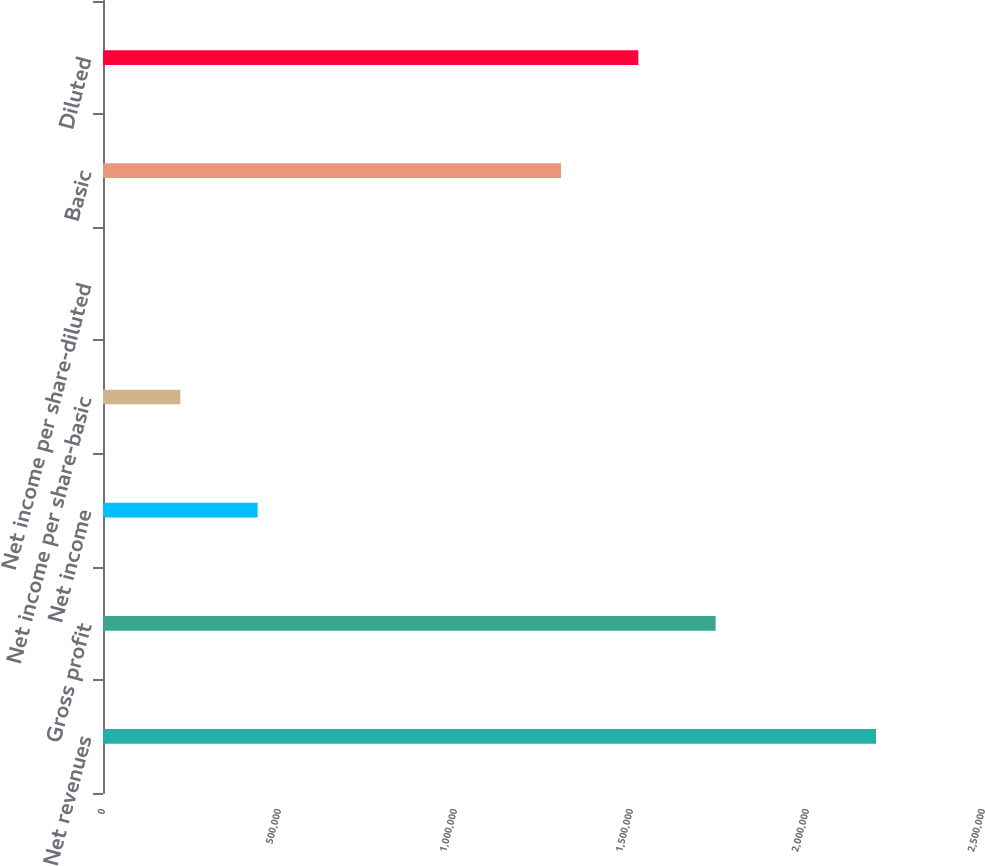<chart> <loc_0><loc_0><loc_500><loc_500><bar_chart><fcel>Net revenues<fcel>Gross profit<fcel>Net income<fcel>Net income per share-basic<fcel>Net income per share-diluted<fcel>Basic<fcel>Diluted<nl><fcel>2.19606e+06<fcel>1.74046e+06<fcel>439212<fcel>219606<fcel>0.3<fcel>1.30125e+06<fcel>1.52085e+06<nl></chart> 